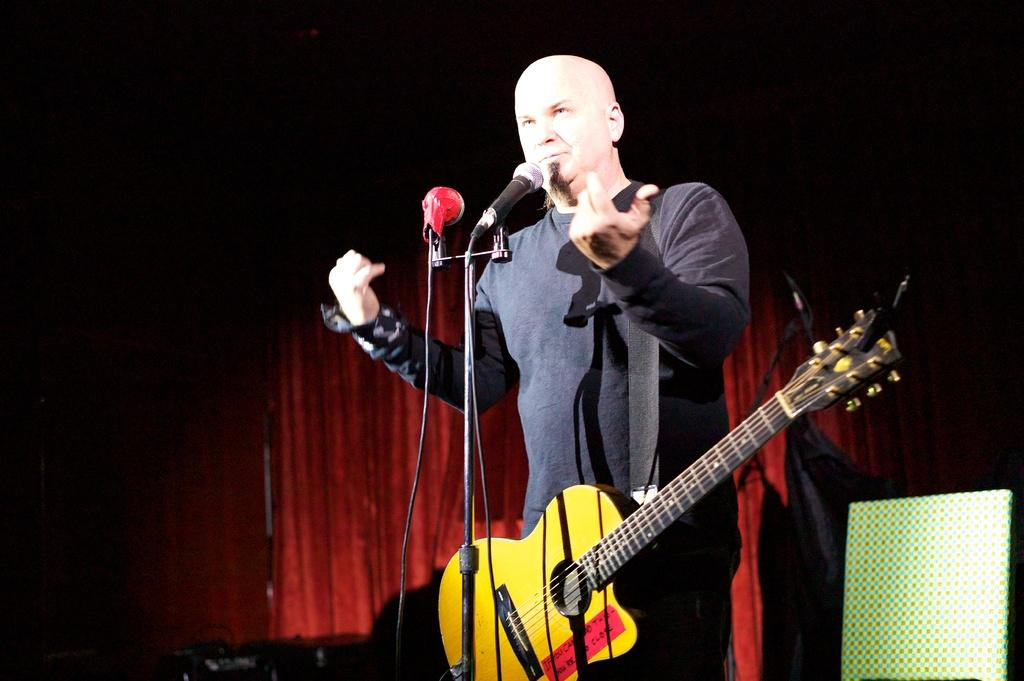Who is the main subject in the image? There is a man in the image. What is the man doing in the image? The man is singing. What is the man holding in the image? The man is holding a microphone and a guitar. What can be seen in the background of the image? There is a curtain in the background of the image. Where is the sister of the man in the image? There is no mention of a sister in the image, so we cannot determine her location. What type of wrench is the man using in the image? There is no wrench present in the image; the man is holding a microphone and a guitar. 